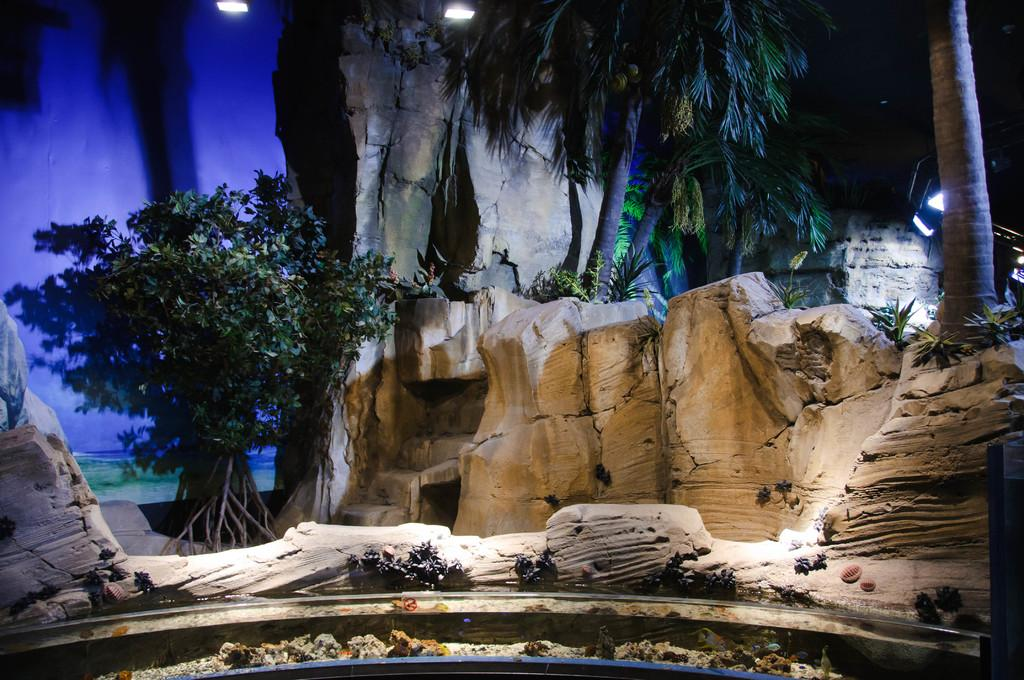What type of natural elements can be seen in the image? There are rocks, trees with branches and leaves, and small plants in the image. Can you describe the trees in the image? The trees in the image have branches and leaves. What else is visible in the image besides the natural elements? There are lights visible at the top of the image. How many girls are standing near the rocks in the image? There are no girls present in the image; it only features natural elements such as rocks, trees, and small plants. Who is the owner of the cannon in the image? There is no cannon present in the image. 